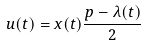Convert formula to latex. <formula><loc_0><loc_0><loc_500><loc_500>u ( t ) = x ( t ) \frac { p - \lambda ( t ) } { 2 }</formula> 